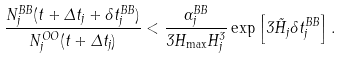<formula> <loc_0><loc_0><loc_500><loc_500>\frac { N _ { j } ^ { B B } ( t + \Delta t _ { j } + \delta t _ { j } ^ { B B } ) } { N _ { j } ^ { O O } ( t + \Delta t _ { j } ) } < \frac { \Gamma _ { j } ^ { B B } } { 3 H _ { \max } H _ { j } ^ { 3 } } \exp \left [ 3 \tilde { H } _ { j } \delta t _ { j } ^ { B B } \right ] .</formula> 